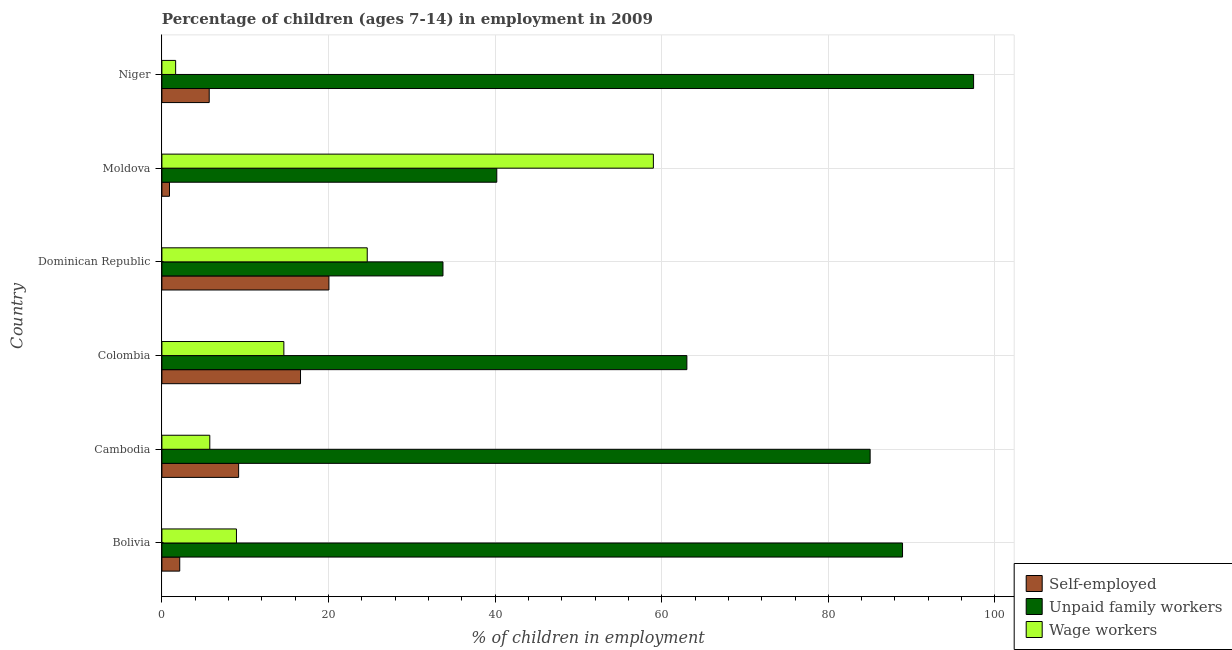Are the number of bars on each tick of the Y-axis equal?
Keep it short and to the point. Yes. What is the label of the 3rd group of bars from the top?
Provide a short and direct response. Dominican Republic. What is the percentage of children employed as wage workers in Bolivia?
Provide a short and direct response. 8.95. Across all countries, what is the maximum percentage of children employed as unpaid family workers?
Offer a terse response. 97.44. Across all countries, what is the minimum percentage of children employed as wage workers?
Ensure brevity in your answer.  1.65. In which country was the percentage of children employed as wage workers maximum?
Your response must be concise. Moldova. In which country was the percentage of self employed children minimum?
Ensure brevity in your answer.  Moldova. What is the total percentage of children employed as wage workers in the graph?
Offer a very short reply. 114.64. What is the difference between the percentage of children employed as unpaid family workers in Colombia and that in Niger?
Your answer should be very brief. -34.42. What is the difference between the percentage of self employed children in Colombia and the percentage of children employed as unpaid family workers in Bolivia?
Your response must be concise. -72.27. What is the average percentage of self employed children per country?
Offer a very short reply. 9.11. What is the difference between the percentage of children employed as unpaid family workers and percentage of children employed as wage workers in Colombia?
Offer a terse response. 48.38. In how many countries, is the percentage of children employed as wage workers greater than 96 %?
Offer a terse response. 0. What is the ratio of the percentage of children employed as unpaid family workers in Cambodia to that in Moldova?
Keep it short and to the point. 2.12. Is the difference between the percentage of children employed as wage workers in Bolivia and Niger greater than the difference between the percentage of children employed as unpaid family workers in Bolivia and Niger?
Ensure brevity in your answer.  Yes. What is the difference between the highest and the second highest percentage of children employed as wage workers?
Your answer should be very brief. 34.35. What is the difference between the highest and the lowest percentage of self employed children?
Provide a succinct answer. 19.14. In how many countries, is the percentage of children employed as unpaid family workers greater than the average percentage of children employed as unpaid family workers taken over all countries?
Ensure brevity in your answer.  3. What does the 3rd bar from the top in Cambodia represents?
Provide a succinct answer. Self-employed. What does the 2nd bar from the bottom in Moldova represents?
Your answer should be compact. Unpaid family workers. How many bars are there?
Keep it short and to the point. 18. Are all the bars in the graph horizontal?
Ensure brevity in your answer.  Yes. Are the values on the major ticks of X-axis written in scientific E-notation?
Ensure brevity in your answer.  No. Where does the legend appear in the graph?
Ensure brevity in your answer.  Bottom right. How many legend labels are there?
Keep it short and to the point. 3. What is the title of the graph?
Your answer should be very brief. Percentage of children (ages 7-14) in employment in 2009. What is the label or title of the X-axis?
Offer a terse response. % of children in employment. What is the label or title of the Y-axis?
Your response must be concise. Country. What is the % of children in employment of Self-employed in Bolivia?
Provide a short and direct response. 2.14. What is the % of children in employment of Unpaid family workers in Bolivia?
Your answer should be compact. 88.91. What is the % of children in employment in Wage workers in Bolivia?
Make the answer very short. 8.95. What is the % of children in employment of Self-employed in Cambodia?
Provide a short and direct response. 9.21. What is the % of children in employment in Unpaid family workers in Cambodia?
Give a very brief answer. 85.02. What is the % of children in employment in Wage workers in Cambodia?
Ensure brevity in your answer.  5.75. What is the % of children in employment of Self-employed in Colombia?
Your answer should be very brief. 16.64. What is the % of children in employment of Unpaid family workers in Colombia?
Your response must be concise. 63.02. What is the % of children in employment of Wage workers in Colombia?
Your answer should be very brief. 14.64. What is the % of children in employment in Self-employed in Dominican Republic?
Provide a succinct answer. 20.05. What is the % of children in employment in Unpaid family workers in Dominican Republic?
Offer a very short reply. 33.74. What is the % of children in employment in Wage workers in Dominican Republic?
Ensure brevity in your answer.  24.65. What is the % of children in employment of Self-employed in Moldova?
Provide a short and direct response. 0.91. What is the % of children in employment of Unpaid family workers in Moldova?
Keep it short and to the point. 40.2. What is the % of children in employment of Wage workers in Moldova?
Make the answer very short. 59. What is the % of children in employment of Self-employed in Niger?
Provide a succinct answer. 5.68. What is the % of children in employment in Unpaid family workers in Niger?
Your answer should be compact. 97.44. What is the % of children in employment of Wage workers in Niger?
Your response must be concise. 1.65. Across all countries, what is the maximum % of children in employment in Self-employed?
Make the answer very short. 20.05. Across all countries, what is the maximum % of children in employment in Unpaid family workers?
Your answer should be compact. 97.44. Across all countries, what is the maximum % of children in employment of Wage workers?
Keep it short and to the point. 59. Across all countries, what is the minimum % of children in employment of Self-employed?
Give a very brief answer. 0.91. Across all countries, what is the minimum % of children in employment of Unpaid family workers?
Your answer should be compact. 33.74. Across all countries, what is the minimum % of children in employment in Wage workers?
Your response must be concise. 1.65. What is the total % of children in employment in Self-employed in the graph?
Your answer should be compact. 54.63. What is the total % of children in employment in Unpaid family workers in the graph?
Your response must be concise. 408.33. What is the total % of children in employment of Wage workers in the graph?
Provide a succinct answer. 114.64. What is the difference between the % of children in employment of Self-employed in Bolivia and that in Cambodia?
Your response must be concise. -7.07. What is the difference between the % of children in employment of Unpaid family workers in Bolivia and that in Cambodia?
Keep it short and to the point. 3.89. What is the difference between the % of children in employment in Wage workers in Bolivia and that in Cambodia?
Your response must be concise. 3.2. What is the difference between the % of children in employment of Unpaid family workers in Bolivia and that in Colombia?
Your response must be concise. 25.89. What is the difference between the % of children in employment of Wage workers in Bolivia and that in Colombia?
Your answer should be very brief. -5.69. What is the difference between the % of children in employment in Self-employed in Bolivia and that in Dominican Republic?
Your answer should be compact. -17.91. What is the difference between the % of children in employment of Unpaid family workers in Bolivia and that in Dominican Republic?
Ensure brevity in your answer.  55.17. What is the difference between the % of children in employment of Wage workers in Bolivia and that in Dominican Republic?
Provide a short and direct response. -15.7. What is the difference between the % of children in employment in Self-employed in Bolivia and that in Moldova?
Your answer should be very brief. 1.23. What is the difference between the % of children in employment in Unpaid family workers in Bolivia and that in Moldova?
Your answer should be compact. 48.71. What is the difference between the % of children in employment of Wage workers in Bolivia and that in Moldova?
Provide a short and direct response. -50.05. What is the difference between the % of children in employment of Self-employed in Bolivia and that in Niger?
Your response must be concise. -3.54. What is the difference between the % of children in employment in Unpaid family workers in Bolivia and that in Niger?
Keep it short and to the point. -8.53. What is the difference between the % of children in employment of Self-employed in Cambodia and that in Colombia?
Provide a succinct answer. -7.43. What is the difference between the % of children in employment of Unpaid family workers in Cambodia and that in Colombia?
Provide a short and direct response. 22. What is the difference between the % of children in employment of Wage workers in Cambodia and that in Colombia?
Make the answer very short. -8.89. What is the difference between the % of children in employment in Self-employed in Cambodia and that in Dominican Republic?
Make the answer very short. -10.84. What is the difference between the % of children in employment in Unpaid family workers in Cambodia and that in Dominican Republic?
Give a very brief answer. 51.28. What is the difference between the % of children in employment of Wage workers in Cambodia and that in Dominican Republic?
Your answer should be compact. -18.9. What is the difference between the % of children in employment of Self-employed in Cambodia and that in Moldova?
Your answer should be compact. 8.3. What is the difference between the % of children in employment of Unpaid family workers in Cambodia and that in Moldova?
Your response must be concise. 44.82. What is the difference between the % of children in employment in Wage workers in Cambodia and that in Moldova?
Your response must be concise. -53.25. What is the difference between the % of children in employment in Self-employed in Cambodia and that in Niger?
Make the answer very short. 3.53. What is the difference between the % of children in employment in Unpaid family workers in Cambodia and that in Niger?
Give a very brief answer. -12.42. What is the difference between the % of children in employment in Wage workers in Cambodia and that in Niger?
Provide a succinct answer. 4.1. What is the difference between the % of children in employment of Self-employed in Colombia and that in Dominican Republic?
Offer a very short reply. -3.41. What is the difference between the % of children in employment of Unpaid family workers in Colombia and that in Dominican Republic?
Offer a very short reply. 29.28. What is the difference between the % of children in employment of Wage workers in Colombia and that in Dominican Republic?
Keep it short and to the point. -10.01. What is the difference between the % of children in employment of Self-employed in Colombia and that in Moldova?
Ensure brevity in your answer.  15.73. What is the difference between the % of children in employment in Unpaid family workers in Colombia and that in Moldova?
Give a very brief answer. 22.82. What is the difference between the % of children in employment in Wage workers in Colombia and that in Moldova?
Ensure brevity in your answer.  -44.36. What is the difference between the % of children in employment in Self-employed in Colombia and that in Niger?
Ensure brevity in your answer.  10.96. What is the difference between the % of children in employment in Unpaid family workers in Colombia and that in Niger?
Give a very brief answer. -34.42. What is the difference between the % of children in employment in Wage workers in Colombia and that in Niger?
Make the answer very short. 12.99. What is the difference between the % of children in employment in Self-employed in Dominican Republic and that in Moldova?
Your answer should be very brief. 19.14. What is the difference between the % of children in employment of Unpaid family workers in Dominican Republic and that in Moldova?
Provide a short and direct response. -6.46. What is the difference between the % of children in employment of Wage workers in Dominican Republic and that in Moldova?
Offer a very short reply. -34.35. What is the difference between the % of children in employment in Self-employed in Dominican Republic and that in Niger?
Keep it short and to the point. 14.37. What is the difference between the % of children in employment in Unpaid family workers in Dominican Republic and that in Niger?
Your response must be concise. -63.7. What is the difference between the % of children in employment of Wage workers in Dominican Republic and that in Niger?
Your answer should be compact. 23. What is the difference between the % of children in employment in Self-employed in Moldova and that in Niger?
Your response must be concise. -4.77. What is the difference between the % of children in employment in Unpaid family workers in Moldova and that in Niger?
Your answer should be very brief. -57.24. What is the difference between the % of children in employment of Wage workers in Moldova and that in Niger?
Provide a short and direct response. 57.35. What is the difference between the % of children in employment of Self-employed in Bolivia and the % of children in employment of Unpaid family workers in Cambodia?
Offer a very short reply. -82.88. What is the difference between the % of children in employment of Self-employed in Bolivia and the % of children in employment of Wage workers in Cambodia?
Your answer should be very brief. -3.61. What is the difference between the % of children in employment in Unpaid family workers in Bolivia and the % of children in employment in Wage workers in Cambodia?
Give a very brief answer. 83.16. What is the difference between the % of children in employment in Self-employed in Bolivia and the % of children in employment in Unpaid family workers in Colombia?
Offer a terse response. -60.88. What is the difference between the % of children in employment of Self-employed in Bolivia and the % of children in employment of Wage workers in Colombia?
Your answer should be very brief. -12.5. What is the difference between the % of children in employment of Unpaid family workers in Bolivia and the % of children in employment of Wage workers in Colombia?
Give a very brief answer. 74.27. What is the difference between the % of children in employment of Self-employed in Bolivia and the % of children in employment of Unpaid family workers in Dominican Republic?
Provide a succinct answer. -31.6. What is the difference between the % of children in employment in Self-employed in Bolivia and the % of children in employment in Wage workers in Dominican Republic?
Make the answer very short. -22.51. What is the difference between the % of children in employment in Unpaid family workers in Bolivia and the % of children in employment in Wage workers in Dominican Republic?
Provide a short and direct response. 64.26. What is the difference between the % of children in employment in Self-employed in Bolivia and the % of children in employment in Unpaid family workers in Moldova?
Your answer should be very brief. -38.06. What is the difference between the % of children in employment in Self-employed in Bolivia and the % of children in employment in Wage workers in Moldova?
Give a very brief answer. -56.86. What is the difference between the % of children in employment in Unpaid family workers in Bolivia and the % of children in employment in Wage workers in Moldova?
Make the answer very short. 29.91. What is the difference between the % of children in employment of Self-employed in Bolivia and the % of children in employment of Unpaid family workers in Niger?
Ensure brevity in your answer.  -95.3. What is the difference between the % of children in employment in Self-employed in Bolivia and the % of children in employment in Wage workers in Niger?
Your answer should be compact. 0.49. What is the difference between the % of children in employment in Unpaid family workers in Bolivia and the % of children in employment in Wage workers in Niger?
Keep it short and to the point. 87.26. What is the difference between the % of children in employment of Self-employed in Cambodia and the % of children in employment of Unpaid family workers in Colombia?
Make the answer very short. -53.81. What is the difference between the % of children in employment in Self-employed in Cambodia and the % of children in employment in Wage workers in Colombia?
Keep it short and to the point. -5.43. What is the difference between the % of children in employment in Unpaid family workers in Cambodia and the % of children in employment in Wage workers in Colombia?
Ensure brevity in your answer.  70.38. What is the difference between the % of children in employment in Self-employed in Cambodia and the % of children in employment in Unpaid family workers in Dominican Republic?
Keep it short and to the point. -24.53. What is the difference between the % of children in employment in Self-employed in Cambodia and the % of children in employment in Wage workers in Dominican Republic?
Keep it short and to the point. -15.44. What is the difference between the % of children in employment of Unpaid family workers in Cambodia and the % of children in employment of Wage workers in Dominican Republic?
Ensure brevity in your answer.  60.37. What is the difference between the % of children in employment in Self-employed in Cambodia and the % of children in employment in Unpaid family workers in Moldova?
Make the answer very short. -30.99. What is the difference between the % of children in employment in Self-employed in Cambodia and the % of children in employment in Wage workers in Moldova?
Provide a succinct answer. -49.79. What is the difference between the % of children in employment in Unpaid family workers in Cambodia and the % of children in employment in Wage workers in Moldova?
Keep it short and to the point. 26.02. What is the difference between the % of children in employment of Self-employed in Cambodia and the % of children in employment of Unpaid family workers in Niger?
Your answer should be very brief. -88.23. What is the difference between the % of children in employment in Self-employed in Cambodia and the % of children in employment in Wage workers in Niger?
Keep it short and to the point. 7.56. What is the difference between the % of children in employment of Unpaid family workers in Cambodia and the % of children in employment of Wage workers in Niger?
Your answer should be compact. 83.37. What is the difference between the % of children in employment of Self-employed in Colombia and the % of children in employment of Unpaid family workers in Dominican Republic?
Give a very brief answer. -17.1. What is the difference between the % of children in employment of Self-employed in Colombia and the % of children in employment of Wage workers in Dominican Republic?
Provide a succinct answer. -8.01. What is the difference between the % of children in employment in Unpaid family workers in Colombia and the % of children in employment in Wage workers in Dominican Republic?
Offer a very short reply. 38.37. What is the difference between the % of children in employment in Self-employed in Colombia and the % of children in employment in Unpaid family workers in Moldova?
Your response must be concise. -23.56. What is the difference between the % of children in employment in Self-employed in Colombia and the % of children in employment in Wage workers in Moldova?
Offer a terse response. -42.36. What is the difference between the % of children in employment of Unpaid family workers in Colombia and the % of children in employment of Wage workers in Moldova?
Provide a short and direct response. 4.02. What is the difference between the % of children in employment of Self-employed in Colombia and the % of children in employment of Unpaid family workers in Niger?
Your response must be concise. -80.8. What is the difference between the % of children in employment in Self-employed in Colombia and the % of children in employment in Wage workers in Niger?
Ensure brevity in your answer.  14.99. What is the difference between the % of children in employment in Unpaid family workers in Colombia and the % of children in employment in Wage workers in Niger?
Your answer should be very brief. 61.37. What is the difference between the % of children in employment of Self-employed in Dominican Republic and the % of children in employment of Unpaid family workers in Moldova?
Make the answer very short. -20.15. What is the difference between the % of children in employment in Self-employed in Dominican Republic and the % of children in employment in Wage workers in Moldova?
Keep it short and to the point. -38.95. What is the difference between the % of children in employment of Unpaid family workers in Dominican Republic and the % of children in employment of Wage workers in Moldova?
Your answer should be compact. -25.26. What is the difference between the % of children in employment of Self-employed in Dominican Republic and the % of children in employment of Unpaid family workers in Niger?
Offer a terse response. -77.39. What is the difference between the % of children in employment of Unpaid family workers in Dominican Republic and the % of children in employment of Wage workers in Niger?
Make the answer very short. 32.09. What is the difference between the % of children in employment in Self-employed in Moldova and the % of children in employment in Unpaid family workers in Niger?
Offer a terse response. -96.53. What is the difference between the % of children in employment in Self-employed in Moldova and the % of children in employment in Wage workers in Niger?
Your response must be concise. -0.74. What is the difference between the % of children in employment in Unpaid family workers in Moldova and the % of children in employment in Wage workers in Niger?
Keep it short and to the point. 38.55. What is the average % of children in employment in Self-employed per country?
Ensure brevity in your answer.  9.11. What is the average % of children in employment in Unpaid family workers per country?
Your answer should be very brief. 68.06. What is the average % of children in employment in Wage workers per country?
Provide a succinct answer. 19.11. What is the difference between the % of children in employment in Self-employed and % of children in employment in Unpaid family workers in Bolivia?
Provide a short and direct response. -86.77. What is the difference between the % of children in employment in Self-employed and % of children in employment in Wage workers in Bolivia?
Your answer should be very brief. -6.81. What is the difference between the % of children in employment in Unpaid family workers and % of children in employment in Wage workers in Bolivia?
Give a very brief answer. 79.96. What is the difference between the % of children in employment of Self-employed and % of children in employment of Unpaid family workers in Cambodia?
Your answer should be compact. -75.81. What is the difference between the % of children in employment of Self-employed and % of children in employment of Wage workers in Cambodia?
Give a very brief answer. 3.46. What is the difference between the % of children in employment in Unpaid family workers and % of children in employment in Wage workers in Cambodia?
Make the answer very short. 79.27. What is the difference between the % of children in employment of Self-employed and % of children in employment of Unpaid family workers in Colombia?
Offer a very short reply. -46.38. What is the difference between the % of children in employment of Self-employed and % of children in employment of Wage workers in Colombia?
Your answer should be very brief. 2. What is the difference between the % of children in employment in Unpaid family workers and % of children in employment in Wage workers in Colombia?
Keep it short and to the point. 48.38. What is the difference between the % of children in employment in Self-employed and % of children in employment in Unpaid family workers in Dominican Republic?
Offer a terse response. -13.69. What is the difference between the % of children in employment of Unpaid family workers and % of children in employment of Wage workers in Dominican Republic?
Offer a terse response. 9.09. What is the difference between the % of children in employment of Self-employed and % of children in employment of Unpaid family workers in Moldova?
Offer a very short reply. -39.29. What is the difference between the % of children in employment in Self-employed and % of children in employment in Wage workers in Moldova?
Provide a succinct answer. -58.09. What is the difference between the % of children in employment of Unpaid family workers and % of children in employment of Wage workers in Moldova?
Give a very brief answer. -18.8. What is the difference between the % of children in employment of Self-employed and % of children in employment of Unpaid family workers in Niger?
Give a very brief answer. -91.76. What is the difference between the % of children in employment of Self-employed and % of children in employment of Wage workers in Niger?
Your response must be concise. 4.03. What is the difference between the % of children in employment in Unpaid family workers and % of children in employment in Wage workers in Niger?
Keep it short and to the point. 95.79. What is the ratio of the % of children in employment of Self-employed in Bolivia to that in Cambodia?
Give a very brief answer. 0.23. What is the ratio of the % of children in employment of Unpaid family workers in Bolivia to that in Cambodia?
Make the answer very short. 1.05. What is the ratio of the % of children in employment in Wage workers in Bolivia to that in Cambodia?
Provide a short and direct response. 1.56. What is the ratio of the % of children in employment of Self-employed in Bolivia to that in Colombia?
Your answer should be compact. 0.13. What is the ratio of the % of children in employment of Unpaid family workers in Bolivia to that in Colombia?
Ensure brevity in your answer.  1.41. What is the ratio of the % of children in employment in Wage workers in Bolivia to that in Colombia?
Provide a short and direct response. 0.61. What is the ratio of the % of children in employment of Self-employed in Bolivia to that in Dominican Republic?
Offer a very short reply. 0.11. What is the ratio of the % of children in employment of Unpaid family workers in Bolivia to that in Dominican Republic?
Offer a terse response. 2.64. What is the ratio of the % of children in employment in Wage workers in Bolivia to that in Dominican Republic?
Give a very brief answer. 0.36. What is the ratio of the % of children in employment of Self-employed in Bolivia to that in Moldova?
Keep it short and to the point. 2.35. What is the ratio of the % of children in employment of Unpaid family workers in Bolivia to that in Moldova?
Give a very brief answer. 2.21. What is the ratio of the % of children in employment of Wage workers in Bolivia to that in Moldova?
Make the answer very short. 0.15. What is the ratio of the % of children in employment of Self-employed in Bolivia to that in Niger?
Provide a succinct answer. 0.38. What is the ratio of the % of children in employment of Unpaid family workers in Bolivia to that in Niger?
Ensure brevity in your answer.  0.91. What is the ratio of the % of children in employment in Wage workers in Bolivia to that in Niger?
Your answer should be very brief. 5.42. What is the ratio of the % of children in employment of Self-employed in Cambodia to that in Colombia?
Keep it short and to the point. 0.55. What is the ratio of the % of children in employment of Unpaid family workers in Cambodia to that in Colombia?
Keep it short and to the point. 1.35. What is the ratio of the % of children in employment of Wage workers in Cambodia to that in Colombia?
Offer a terse response. 0.39. What is the ratio of the % of children in employment in Self-employed in Cambodia to that in Dominican Republic?
Keep it short and to the point. 0.46. What is the ratio of the % of children in employment of Unpaid family workers in Cambodia to that in Dominican Republic?
Your answer should be compact. 2.52. What is the ratio of the % of children in employment in Wage workers in Cambodia to that in Dominican Republic?
Give a very brief answer. 0.23. What is the ratio of the % of children in employment of Self-employed in Cambodia to that in Moldova?
Offer a terse response. 10.12. What is the ratio of the % of children in employment of Unpaid family workers in Cambodia to that in Moldova?
Offer a very short reply. 2.11. What is the ratio of the % of children in employment in Wage workers in Cambodia to that in Moldova?
Your answer should be very brief. 0.1. What is the ratio of the % of children in employment in Self-employed in Cambodia to that in Niger?
Provide a short and direct response. 1.62. What is the ratio of the % of children in employment of Unpaid family workers in Cambodia to that in Niger?
Give a very brief answer. 0.87. What is the ratio of the % of children in employment in Wage workers in Cambodia to that in Niger?
Keep it short and to the point. 3.48. What is the ratio of the % of children in employment of Self-employed in Colombia to that in Dominican Republic?
Provide a succinct answer. 0.83. What is the ratio of the % of children in employment in Unpaid family workers in Colombia to that in Dominican Republic?
Your answer should be very brief. 1.87. What is the ratio of the % of children in employment in Wage workers in Colombia to that in Dominican Republic?
Provide a short and direct response. 0.59. What is the ratio of the % of children in employment in Self-employed in Colombia to that in Moldova?
Give a very brief answer. 18.29. What is the ratio of the % of children in employment in Unpaid family workers in Colombia to that in Moldova?
Provide a succinct answer. 1.57. What is the ratio of the % of children in employment of Wage workers in Colombia to that in Moldova?
Your answer should be compact. 0.25. What is the ratio of the % of children in employment of Self-employed in Colombia to that in Niger?
Your answer should be compact. 2.93. What is the ratio of the % of children in employment of Unpaid family workers in Colombia to that in Niger?
Keep it short and to the point. 0.65. What is the ratio of the % of children in employment of Wage workers in Colombia to that in Niger?
Offer a very short reply. 8.87. What is the ratio of the % of children in employment of Self-employed in Dominican Republic to that in Moldova?
Give a very brief answer. 22.03. What is the ratio of the % of children in employment of Unpaid family workers in Dominican Republic to that in Moldova?
Your response must be concise. 0.84. What is the ratio of the % of children in employment of Wage workers in Dominican Republic to that in Moldova?
Make the answer very short. 0.42. What is the ratio of the % of children in employment in Self-employed in Dominican Republic to that in Niger?
Your answer should be very brief. 3.53. What is the ratio of the % of children in employment of Unpaid family workers in Dominican Republic to that in Niger?
Your answer should be compact. 0.35. What is the ratio of the % of children in employment in Wage workers in Dominican Republic to that in Niger?
Make the answer very short. 14.94. What is the ratio of the % of children in employment in Self-employed in Moldova to that in Niger?
Your answer should be compact. 0.16. What is the ratio of the % of children in employment in Unpaid family workers in Moldova to that in Niger?
Your answer should be very brief. 0.41. What is the ratio of the % of children in employment in Wage workers in Moldova to that in Niger?
Offer a terse response. 35.76. What is the difference between the highest and the second highest % of children in employment in Self-employed?
Offer a terse response. 3.41. What is the difference between the highest and the second highest % of children in employment in Unpaid family workers?
Make the answer very short. 8.53. What is the difference between the highest and the second highest % of children in employment in Wage workers?
Give a very brief answer. 34.35. What is the difference between the highest and the lowest % of children in employment in Self-employed?
Offer a very short reply. 19.14. What is the difference between the highest and the lowest % of children in employment of Unpaid family workers?
Your answer should be compact. 63.7. What is the difference between the highest and the lowest % of children in employment in Wage workers?
Provide a short and direct response. 57.35. 